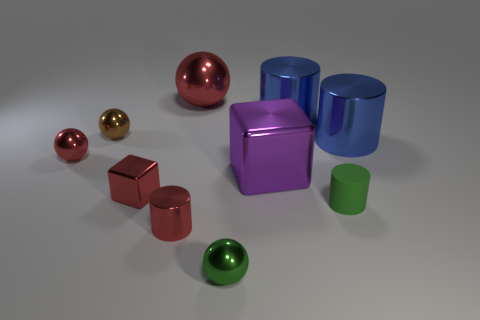Subtract all cyan balls. Subtract all gray cylinders. How many balls are left? 4 Subtract all cylinders. How many objects are left? 6 Subtract 1 green cylinders. How many objects are left? 9 Subtract all large gray metal objects. Subtract all small red metal spheres. How many objects are left? 9 Add 4 tiny red shiny blocks. How many tiny red shiny blocks are left? 5 Add 3 big purple metal cylinders. How many big purple metal cylinders exist? 3 